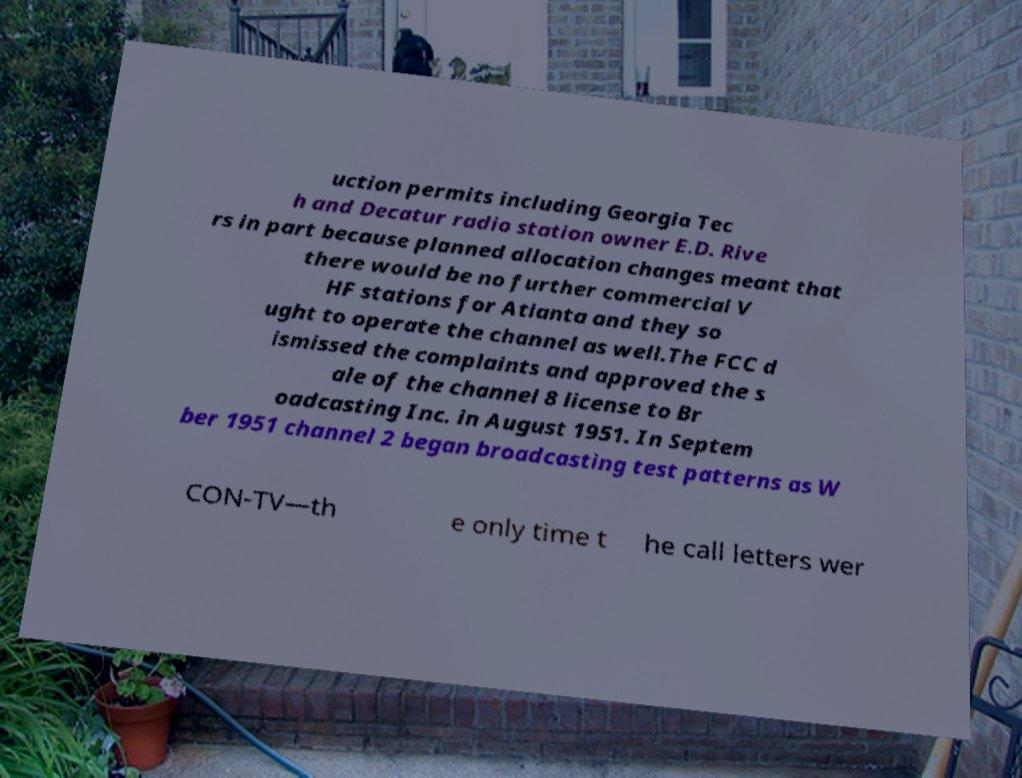For documentation purposes, I need the text within this image transcribed. Could you provide that? uction permits including Georgia Tec h and Decatur radio station owner E.D. Rive rs in part because planned allocation changes meant that there would be no further commercial V HF stations for Atlanta and they so ught to operate the channel as well.The FCC d ismissed the complaints and approved the s ale of the channel 8 license to Br oadcasting Inc. in August 1951. In Septem ber 1951 channel 2 began broadcasting test patterns as W CON-TV—th e only time t he call letters wer 